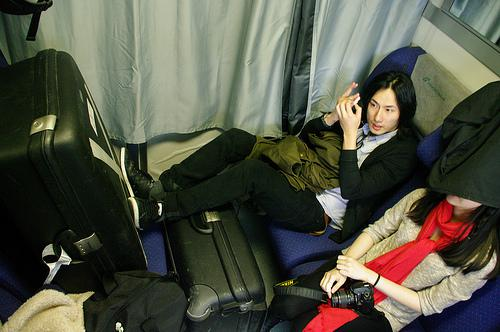Question: who is in the picture?
Choices:
A. Two clowns.
B. Two garbage men.
C. Two babies.
D. Two travelers.
Answer with the letter. Answer: D Question: what race are the people?
Choices:
A. Black.
B. Caucasian.
C. Hispanic.
D. Asian.
Answer with the letter. Answer: D Question: what color is the man's jacket?
Choices:
A. Green.
B. Red.
C. Yellow.
D. Orange.
Answer with the letter. Answer: A Question: what color are the seats?
Choices:
A. Red.
B. Yellow.
C. Orange.
D. Blue.
Answer with the letter. Answer: D 